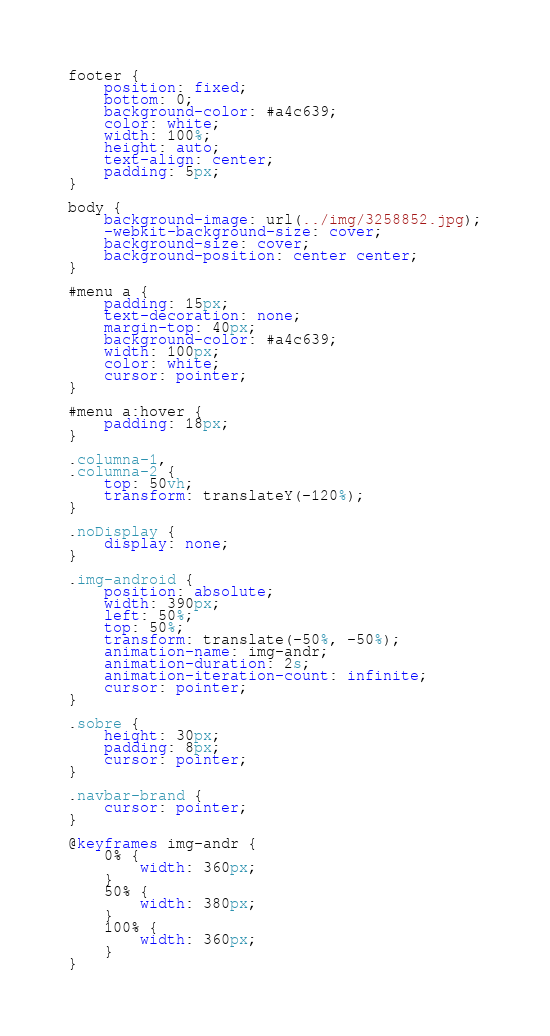<code> <loc_0><loc_0><loc_500><loc_500><_CSS_>footer {
    position: fixed;
    bottom: 0;
    background-color: #a4c639;
    color: white;
    width: 100%;
    height: auto;
    text-align: center;
    padding: 5px;
}

body {
    background-image: url(../img/3258852.jpg);
    -webkit-background-size: cover;
    background-size: cover;
    background-position: center center;
}

#menu a {
    padding: 15px;
    text-decoration: none;
    margin-top: 40px;
    background-color: #a4c639;
    width: 100px;
    color: white;
    cursor: pointer;
}

#menu a:hover {
    padding: 18px;
}

.columna-1,
.columna-2 {
    top: 50vh;
    transform: translateY(-120%);
}

.noDisplay {
    display: none;
}

.img-android {
    position: absolute;
    width: 390px;
    left: 50%;
    top: 50%;
    transform: translate(-50%, -50%);
    animation-name: img-andr;
    animation-duration: 2s;
    animation-iteration-count: infinite;
    cursor: pointer;
}

.sobre {
    height: 30px;
    padding: 8px;
    cursor: pointer;
}

.navbar-brand {
    cursor: pointer;
}

@keyframes img-andr {
    0% {
        width: 360px;
    }
    50% {
        width: 380px;
    }
    100% {
        width: 360px;
    }
}</code> 